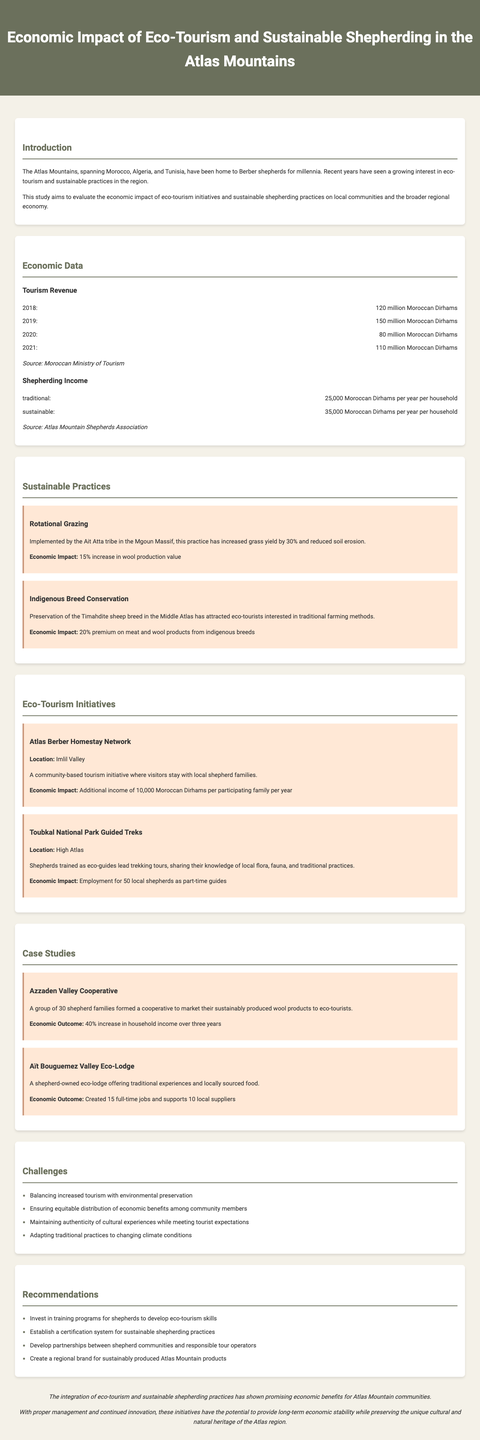What is the report title? The report title is presented at the top of the document.
Answer: Economic Impact of Eco-Tourism and Sustainable Shepherding in the Atlas Mountains What was the tourism revenue in 2019? The tourism revenue for each year is summarized in the economic data section of the report.
Answer: 150 million Moroccan Dirhams How much is the traditional shepherding income per household per year? The report specifies the income figures for traditional shepherding within the economic data section.
Answer: 25,000 Moroccan Dirhams What is the economic impact of rotational grazing? The economic impact of sustainable practices is detailed in the sustainable practices section of the report.
Answer: 15% increase in wool production value How many local shepherds were employed as part-time guides? This information is found in the eco-tourism initiatives section, detailing employment opportunities.
Answer: 50 local shepherds What is the economic outcome for the Azzaden Valley Cooperative? The case studies section provides specific economic outcomes for the case study examples given.
Answer: 40% increase in household income over three years What are some challenges mentioned in the report? The report lists challenges in a dedicated section, highlighting significant issues faced.
Answer: Balancing increased tourism with environmental preservation What recommendation is made for shepherds? Recommendations provided in the report specifically address the needs and skills for shepherds in the context of eco-tourism.
Answer: Invest in training programs for shepherds to develop eco-tourism skills What is the summary of the conclusion? The conclusion section summarizes the findings and implications of the study.
Answer: The integration of eco-tourism and sustainable shepherding practices has shown promising economic benefits for Atlas Mountain communities 